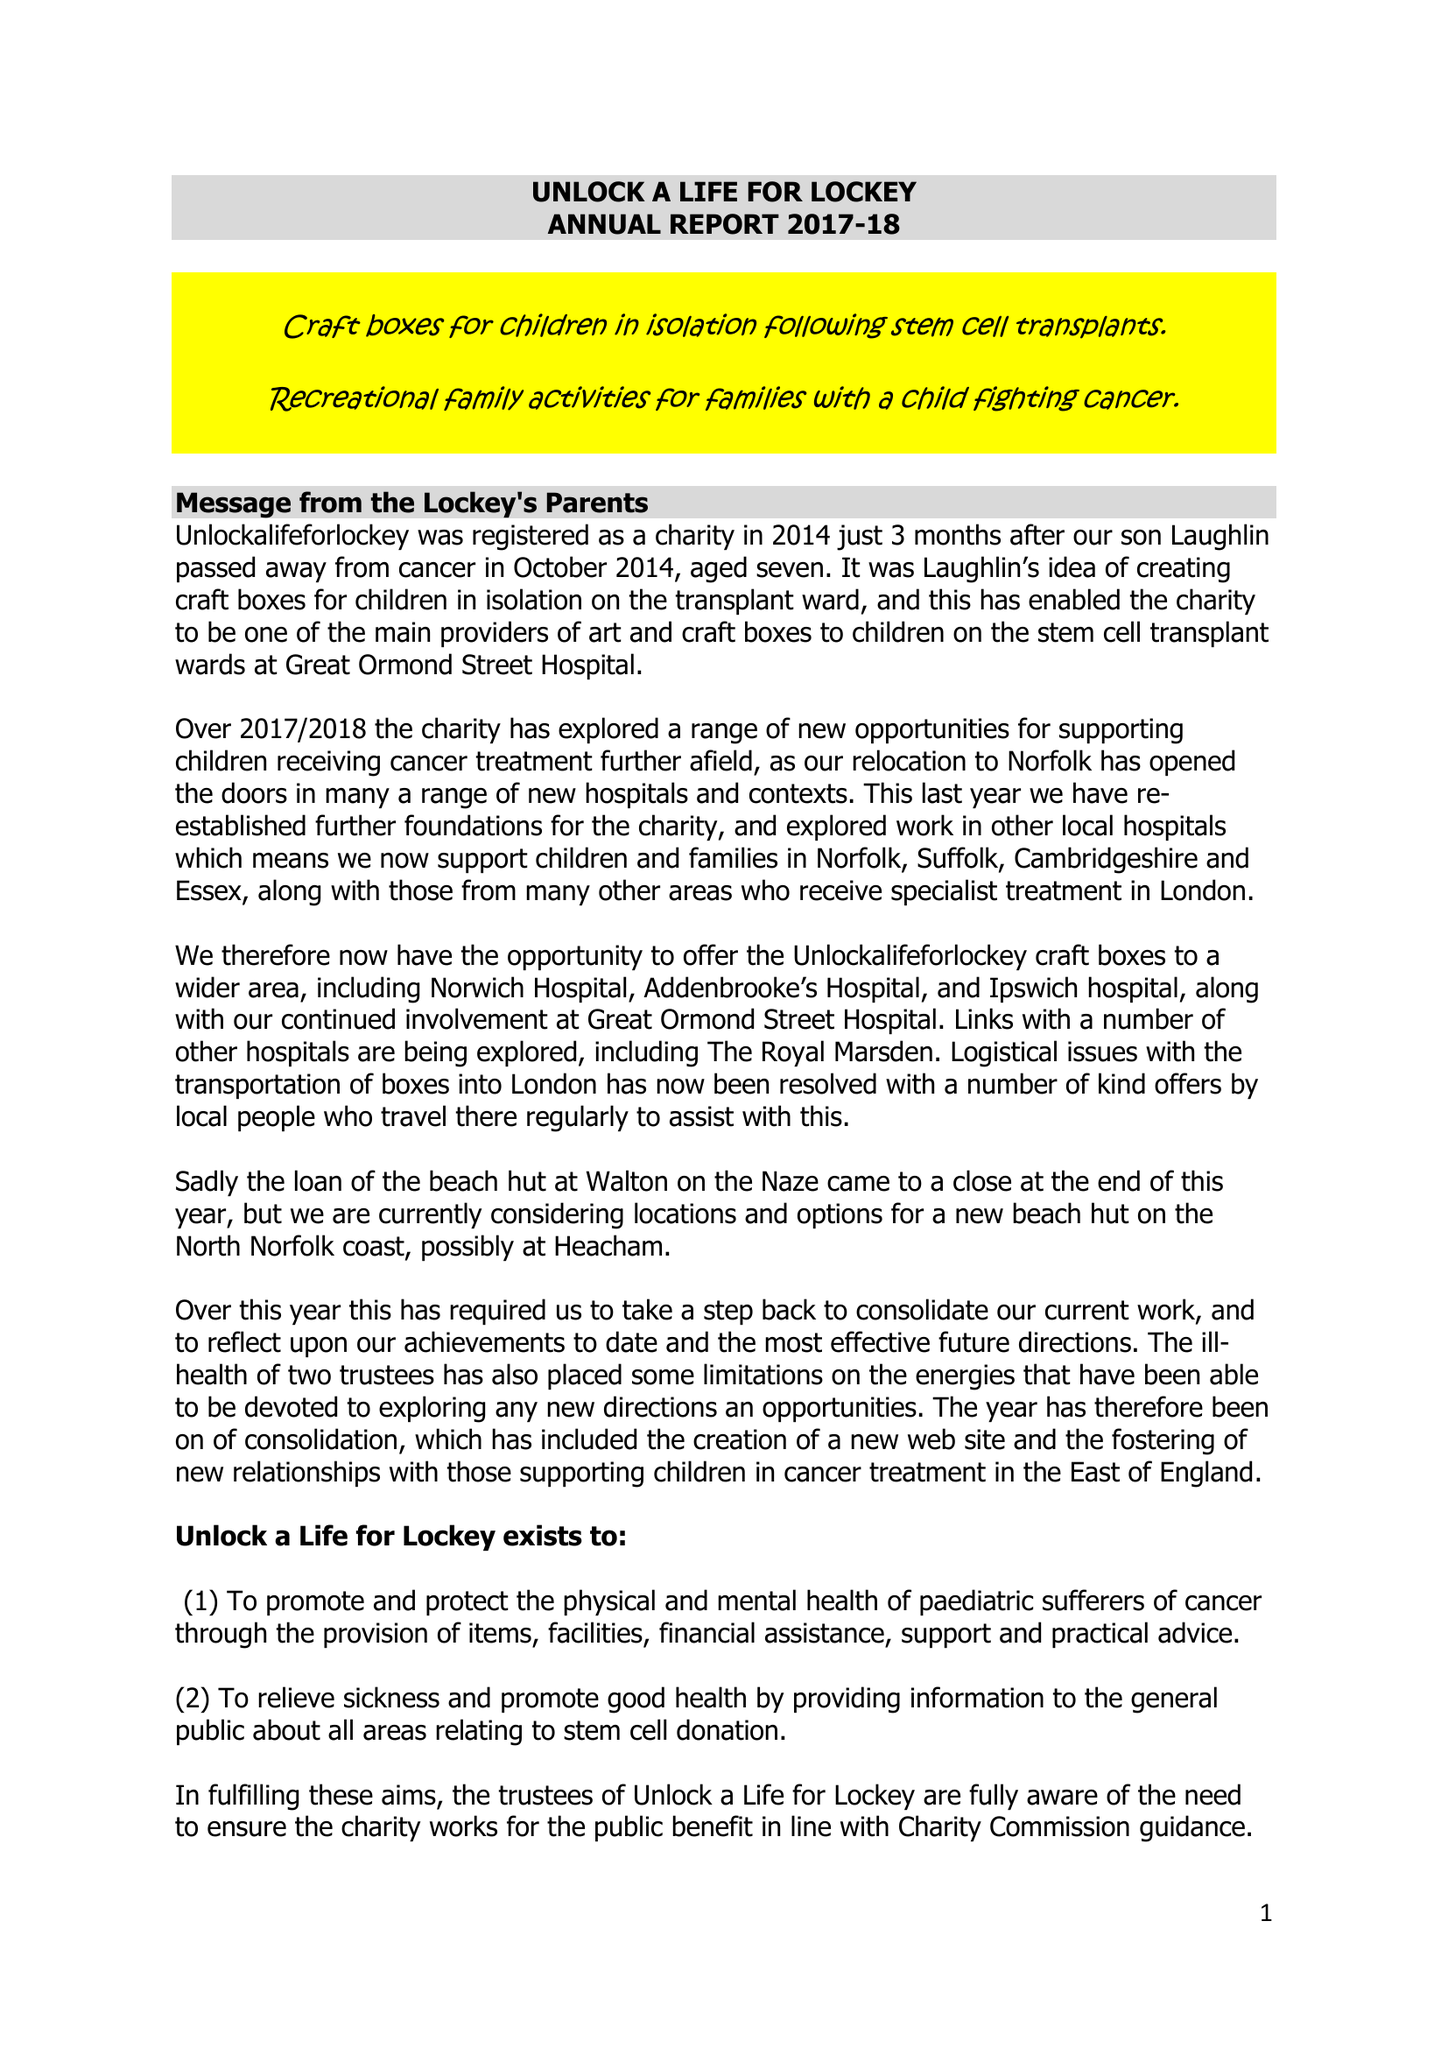What is the value for the address__postcode?
Answer the question using a single word or phrase. IP20 0BT 